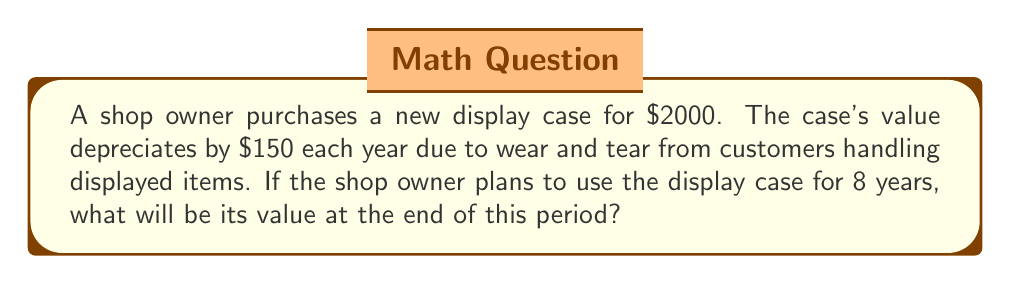Solve this math problem. Let's approach this step-by-step using an arithmetic sequence:

1) The initial value of the display case is $a_1 = 2000$.

2) The common difference (annual depreciation) is $d = -150$.

3) We need to find the 8th term of this sequence, $a_8$.

4) The formula for the nth term of an arithmetic sequence is:

   $$a_n = a_1 + (n - 1)d$$

5) Substituting our values:

   $$a_8 = 2000 + (8 - 1)(-150)$$

6) Simplify:

   $$a_8 = 2000 + 7(-150)$$
   $$a_8 = 2000 - 1050$$
   $$a_8 = 950$$

Therefore, after 8 years, the display case will be worth $950.
Answer: $950 